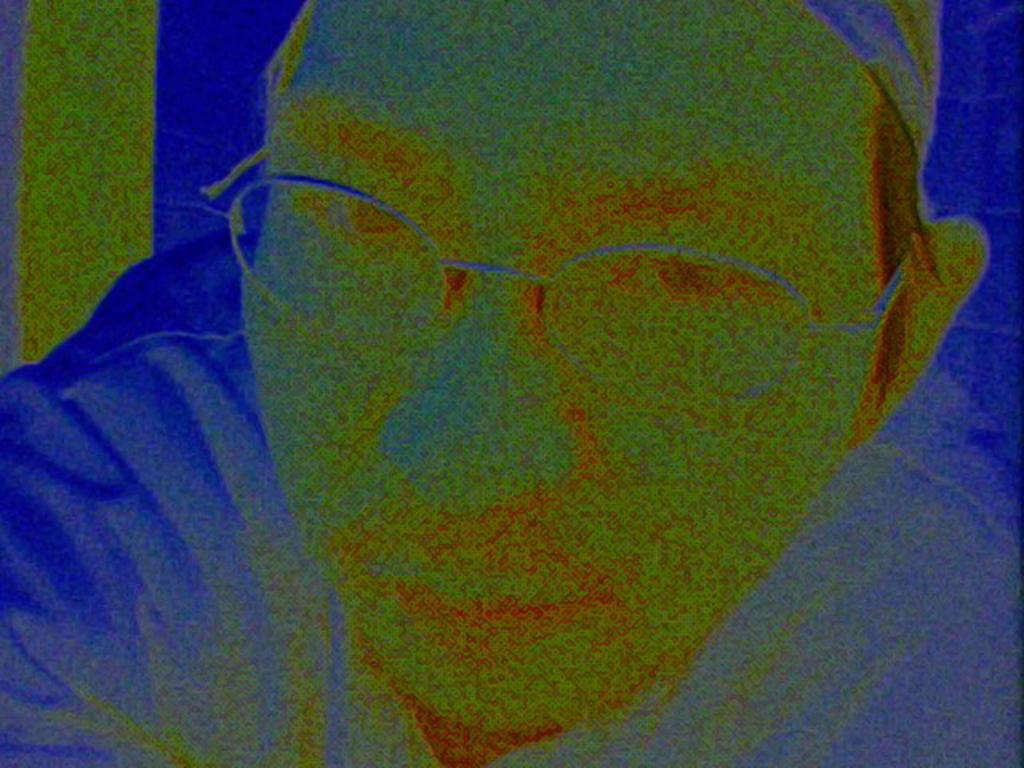What type of image is being described? The image is an edited image. What is the main subject of the image? The image depicts a person. Is the person riding a bike in the image? There is no bike present in the image. What type of rice is being cooked in the image? There is no rice or cooking activity depicted in the image. 